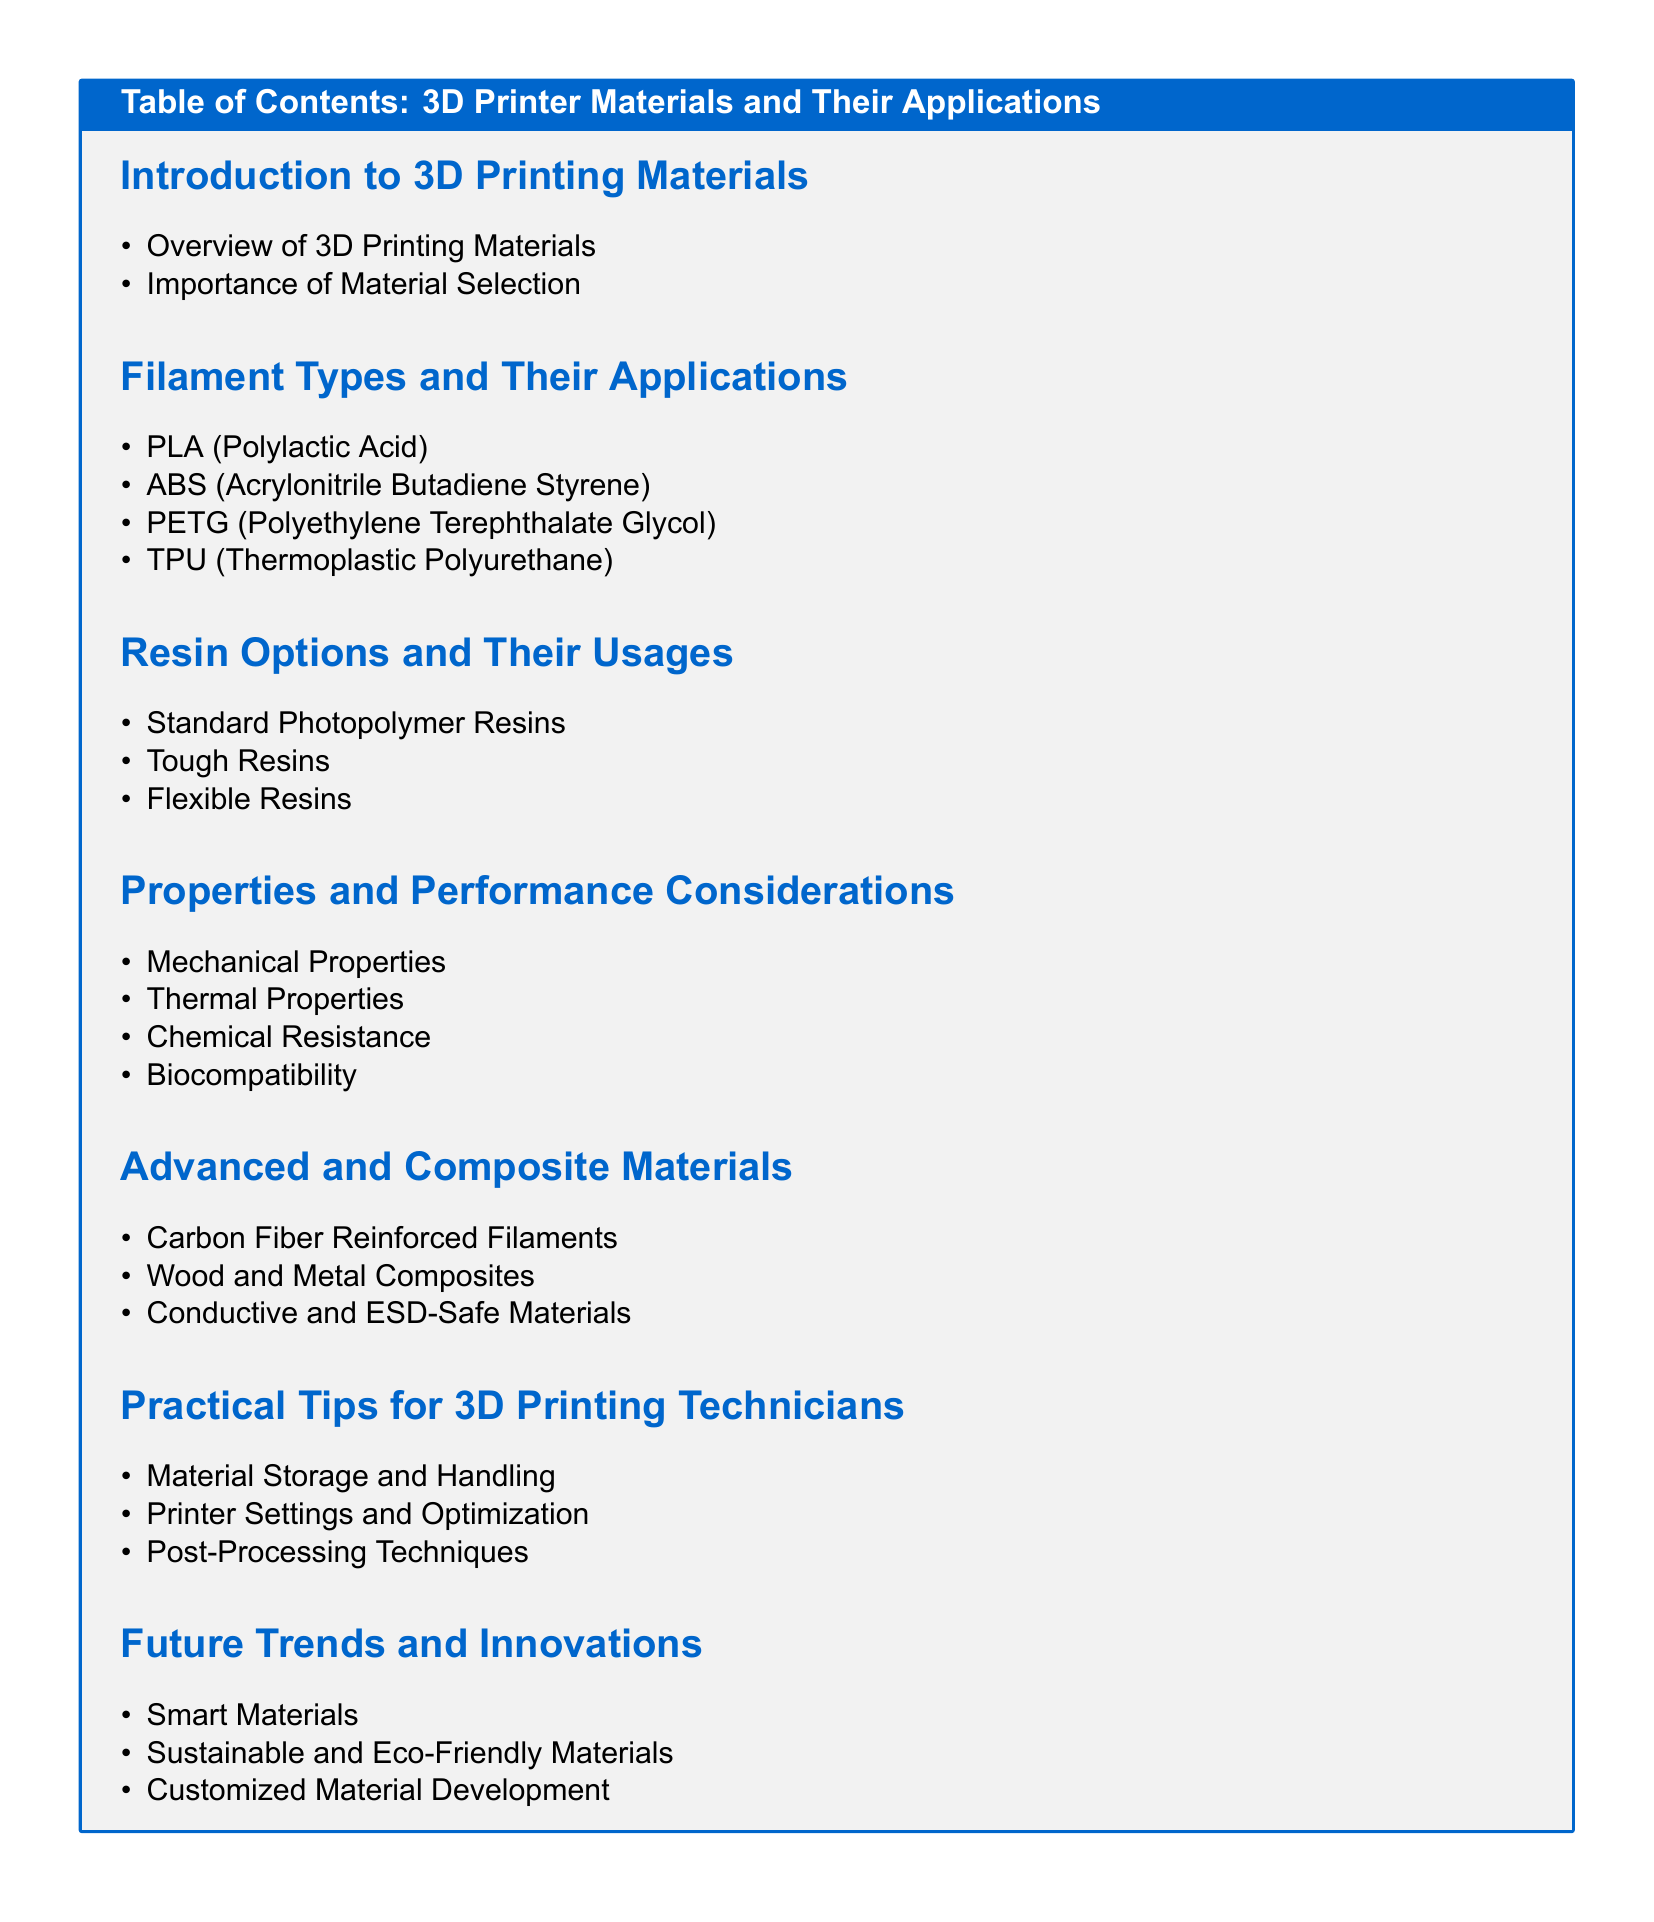What is the first section of the document? The first section of the document is about the introduction to 3D printing materials.
Answer: Introduction to 3D Printing Materials How many types of filament are listed in the document? The document lists four types of filament in the section on filament types.
Answer: Four What material is categorized as a thermoplastic polyurethane? The document lists TPU as a thermoplastic polyurethane.
Answer: TPU Which resin type is known for its toughness? The document mentions tough resins as a category of resin options.
Answer: Tough Resins What type of properties are discussed in the properties and performance considerations section? The section discusses various properties, including mechanical properties.
Answer: Mechanical Properties What advanced material includes carbon fiber reinforcement? Carbon Fiber Reinforced Filaments fall under advanced and composite materials.
Answer: Carbon Fiber Reinforced Filaments What practical tip is included regarding material storage? The document mentions material storage and handling as a practical tip for technicians.
Answer: Material Storage and Handling Which future trend focuses on environment-friendly solutions? Sustainable and eco-friendly materials are highlighted in the future trends section.
Answer: Sustainable and Eco-Friendly Materials What is the main focus of the advanced and composite materials section? The focus is on materials that are enhanced by composites or specific reinforcements.
Answer: Advanced and Composite Materials 